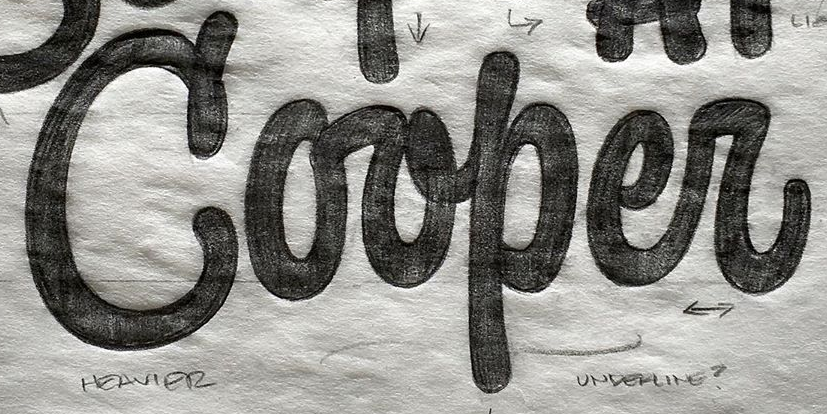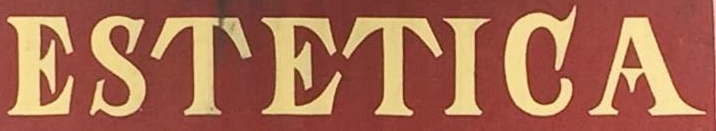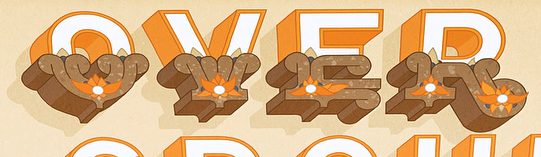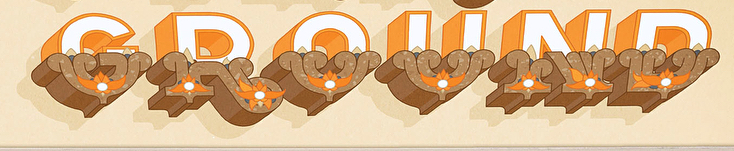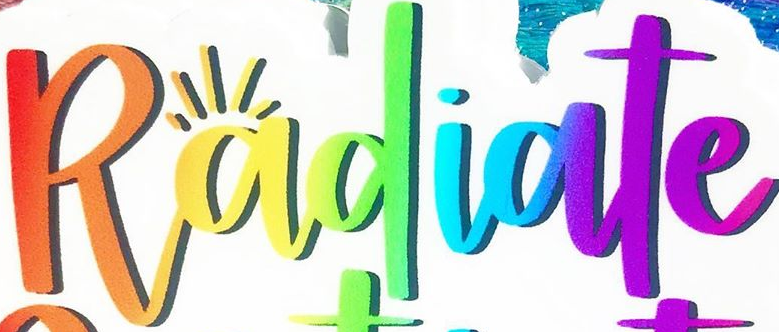What text is displayed in these images sequentially, separated by a semicolon? Corper; ESTETIGA; OVER; GROUND; Radiate 